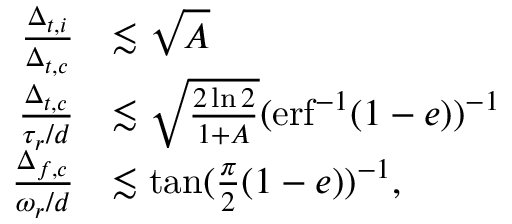<formula> <loc_0><loc_0><loc_500><loc_500>\begin{array} { r l } { \frac { \Delta _ { t , i } } { \Delta _ { t , c } } } & { \lesssim \sqrt { A } } \\ { \frac { \Delta _ { t , c } } { \tau _ { r } / d } } & { \lesssim \sqrt { \frac { 2 \ln { 2 } } { 1 + A } } ( e r f ^ { - 1 } ( 1 - e ) ) ^ { - 1 } } \\ { \frac { \Delta _ { f , c } } { \omega _ { r } / d } } & { \lesssim \tan ( \frac { \pi } { 2 } ( 1 - e ) ) ^ { - 1 } , } \end{array}</formula> 